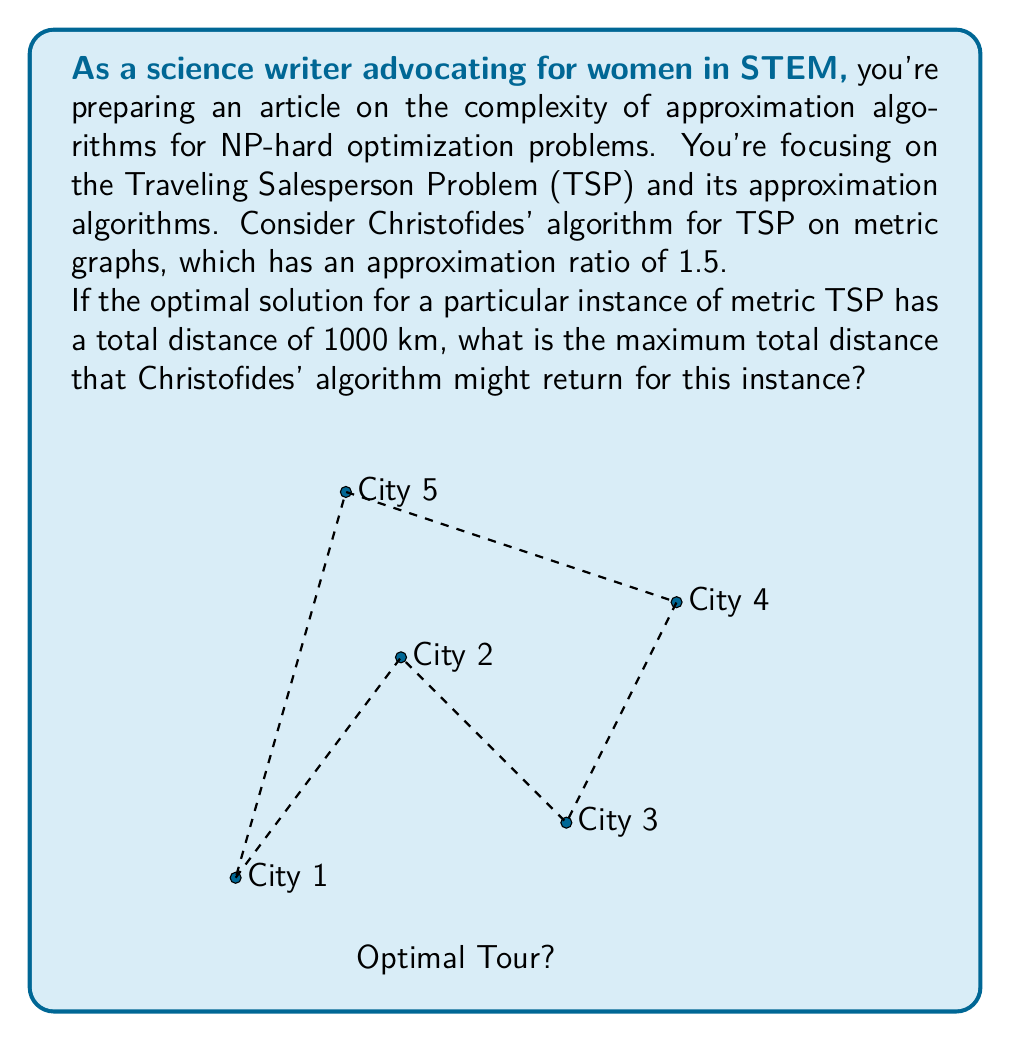Can you answer this question? Let's approach this step-by-step:

1) Christofides' algorithm is a 1.5-approximation algorithm for the metric TSP. This means that for any instance of the problem, the solution returned by the algorithm is guaranteed to be no more than 1.5 times the optimal solution.

2) Mathematically, if we denote the optimal solution as $OPT$ and the solution returned by Christofides' algorithm as $ALG$, we can express this as:

   $$ALG \leq 1.5 \times OPT$$

3) In this case, we're given that the optimal solution (OPT) has a total distance of 1000 km. Let's substitute this into our inequality:

   $$ALG \leq 1.5 \times 1000$$

4) Now, we can simply calculate the right-hand side:

   $$ALG \leq 1500$$

5) This means that the maximum total distance that Christofides' algorithm might return is 1500 km.

It's important to note that this is an upper bound. The algorithm might return a better solution, but it will never exceed 1500 km for this instance.
Answer: 1500 km 